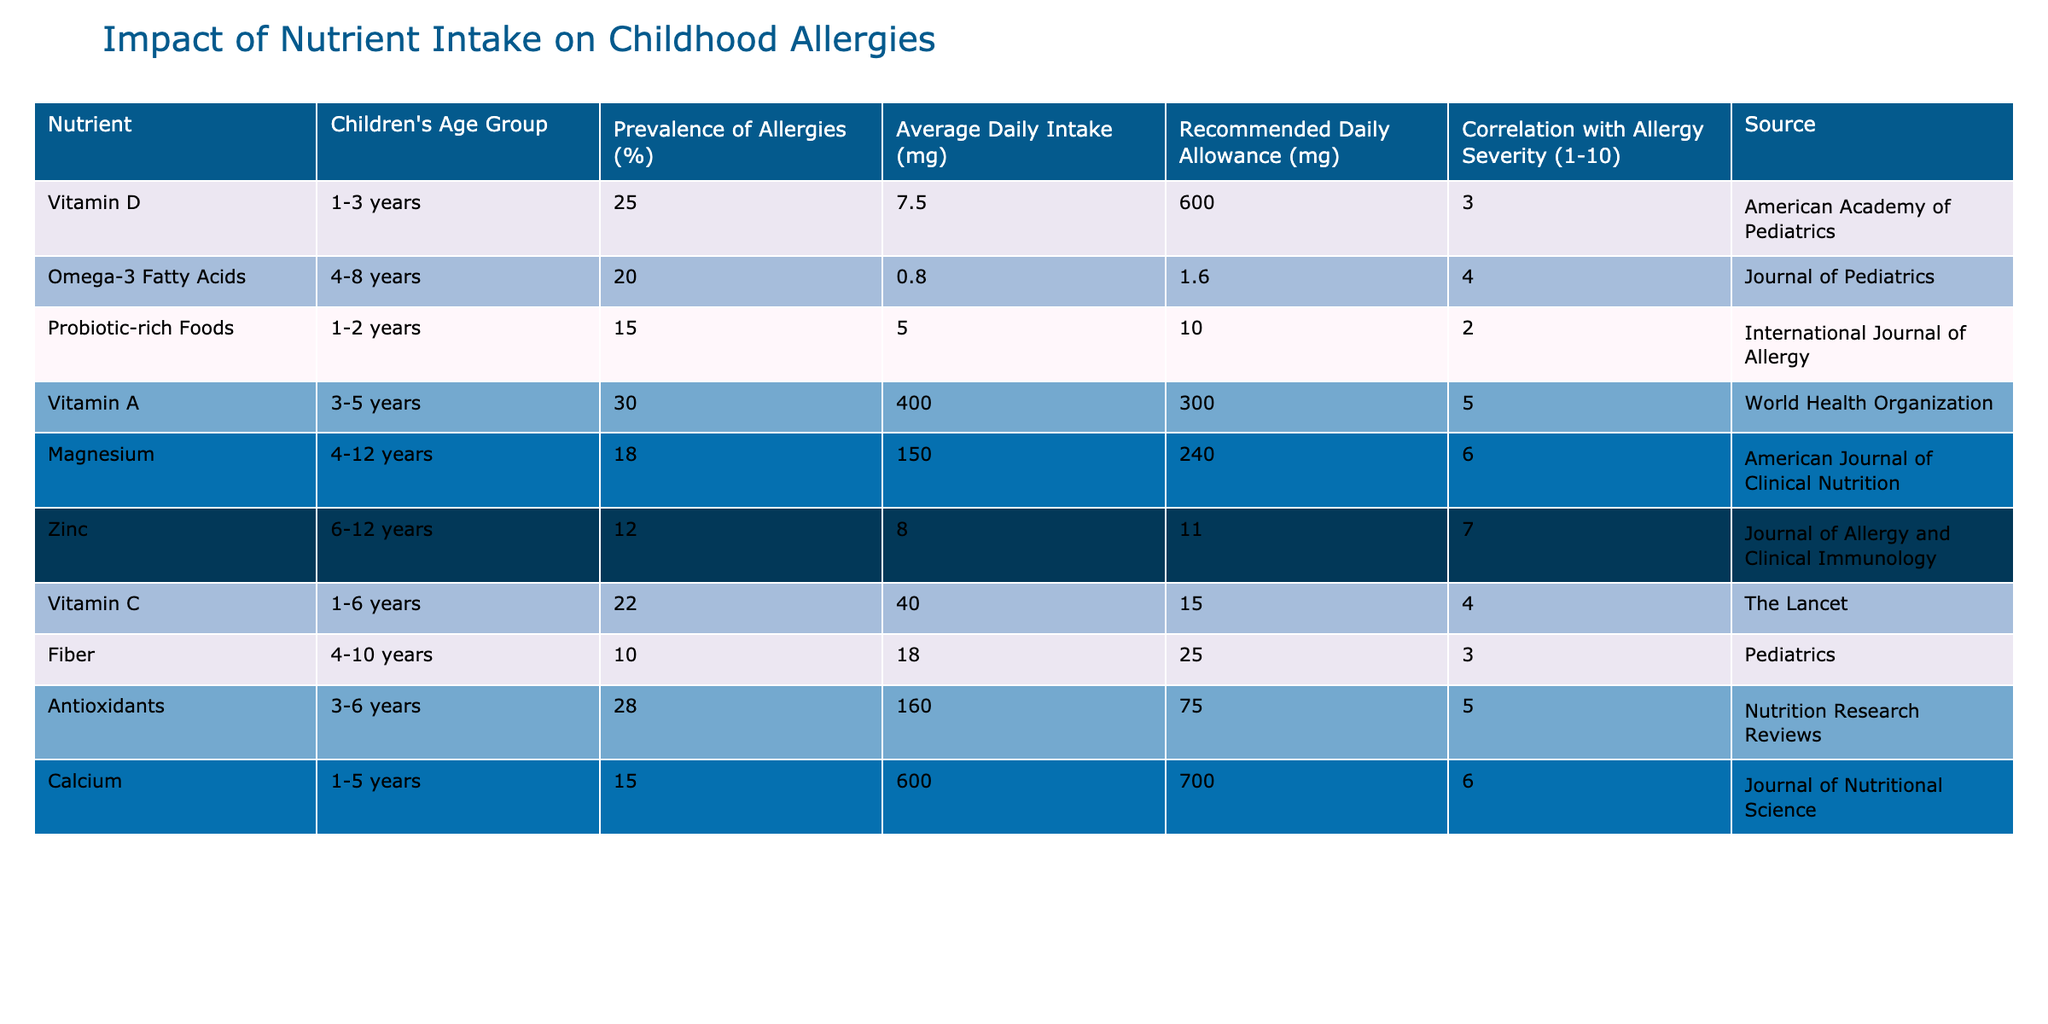What is the prevalence of allergies in the 1-3 years age group? According to the data, the prevalence of allergies for children aged 1-3 years is listed as 25%.
Answer: 25% Which nutrient has the highest correlation with allergy severity? By examining the "Correlation with Allergy Severity" column, we see that Zinc has the highest correlation at a value of 7.
Answer: Zinc What is the average daily intake of Omega-3 Fatty Acids for the 4-8 years age group? The table shows that the average daily intake for Omega-3 Fatty Acids in the 4-8 years age group is 0.8 mg.
Answer: 0.8 mg Is the recommended daily allowance of Vitamin C greater than its average daily intake for children aged 1-6 years? The recommended daily allowance of Vitamin C is 15 mg, while the average daily intake is 40 mg. Since 40 is greater than 15, the answer is yes.
Answer: Yes What is the difference in prevalence of allergies between the 1-2 years and 4-8 years age groups? The prevalence for 1-2 years is 15%, and for 4-8 years, it is 20%. The difference is 20% - 15% = 5%.
Answer: 5% Calculate the average correlation with allergy severity for children aged 3-6 years. The correlation values for that age group are from Vitamin A (5), Antioxidants (5). Adding them gives 10; there are 2 values, so the average is 10/2 = 5.
Answer: 5 What percentage of children aged 6-12 years have allergies? The prevalence of allergies for children aged 6-12 years is stated as 12%.
Answer: 12% Is the average daily intake of Vitamin D less than its recommended daily allowance? The average daily intake for Vitamin D is 7.5 mg, while the recommended daily allowance is 600 mg. Since 7.5 mg is less than 600 mg, the answer is yes.
Answer: Yes How does the average daily intake of Probiotic-rich Foods compare to its recommended daily allowance? Probiotic-rich Foods have an average daily intake of 5 mg and a recommended daily allowance of 10 mg. Since 5 mg is less than 10 mg, the average daily intake is not sufficient.
Answer: Less than What is the nutrient with the lowest prevalence of allergies? Looking through the table, Fiber has the lowest prevalence at 10%.
Answer: Fiber 